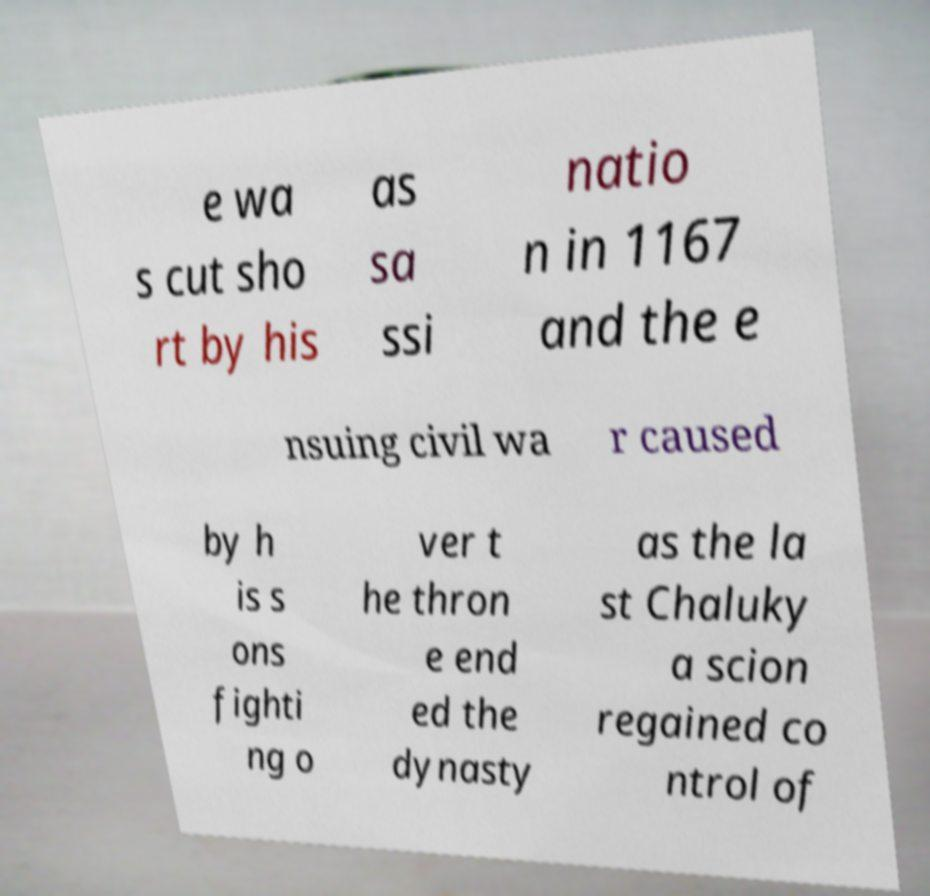Please identify and transcribe the text found in this image. e wa s cut sho rt by his as sa ssi natio n in 1167 and the e nsuing civil wa r caused by h is s ons fighti ng o ver t he thron e end ed the dynasty as the la st Chaluky a scion regained co ntrol of 